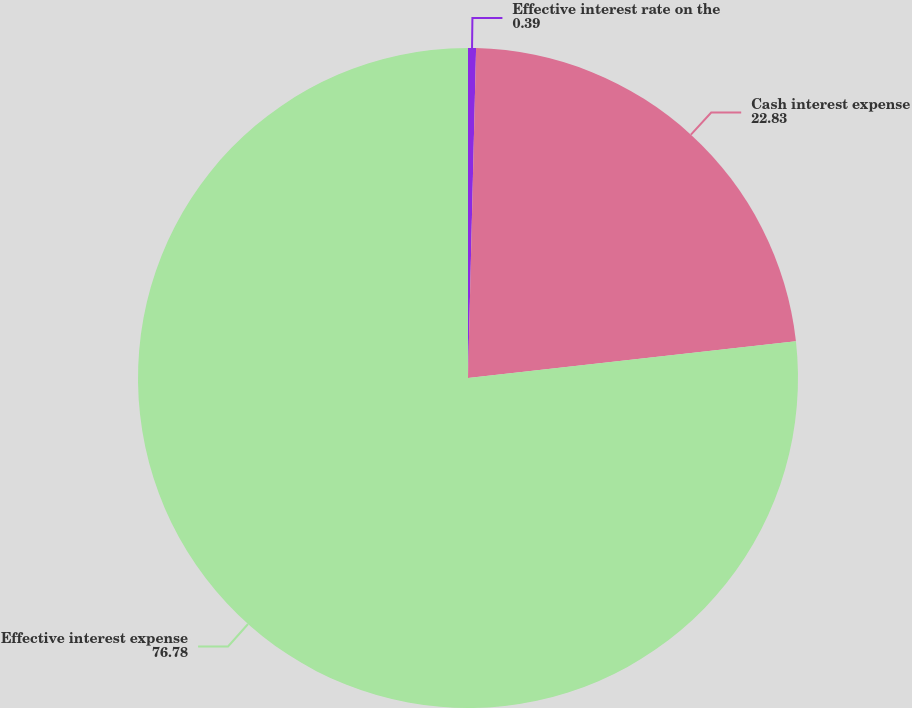Convert chart to OTSL. <chart><loc_0><loc_0><loc_500><loc_500><pie_chart><fcel>Effective interest rate on the<fcel>Cash interest expense<fcel>Effective interest expense<nl><fcel>0.39%<fcel>22.83%<fcel>76.78%<nl></chart> 